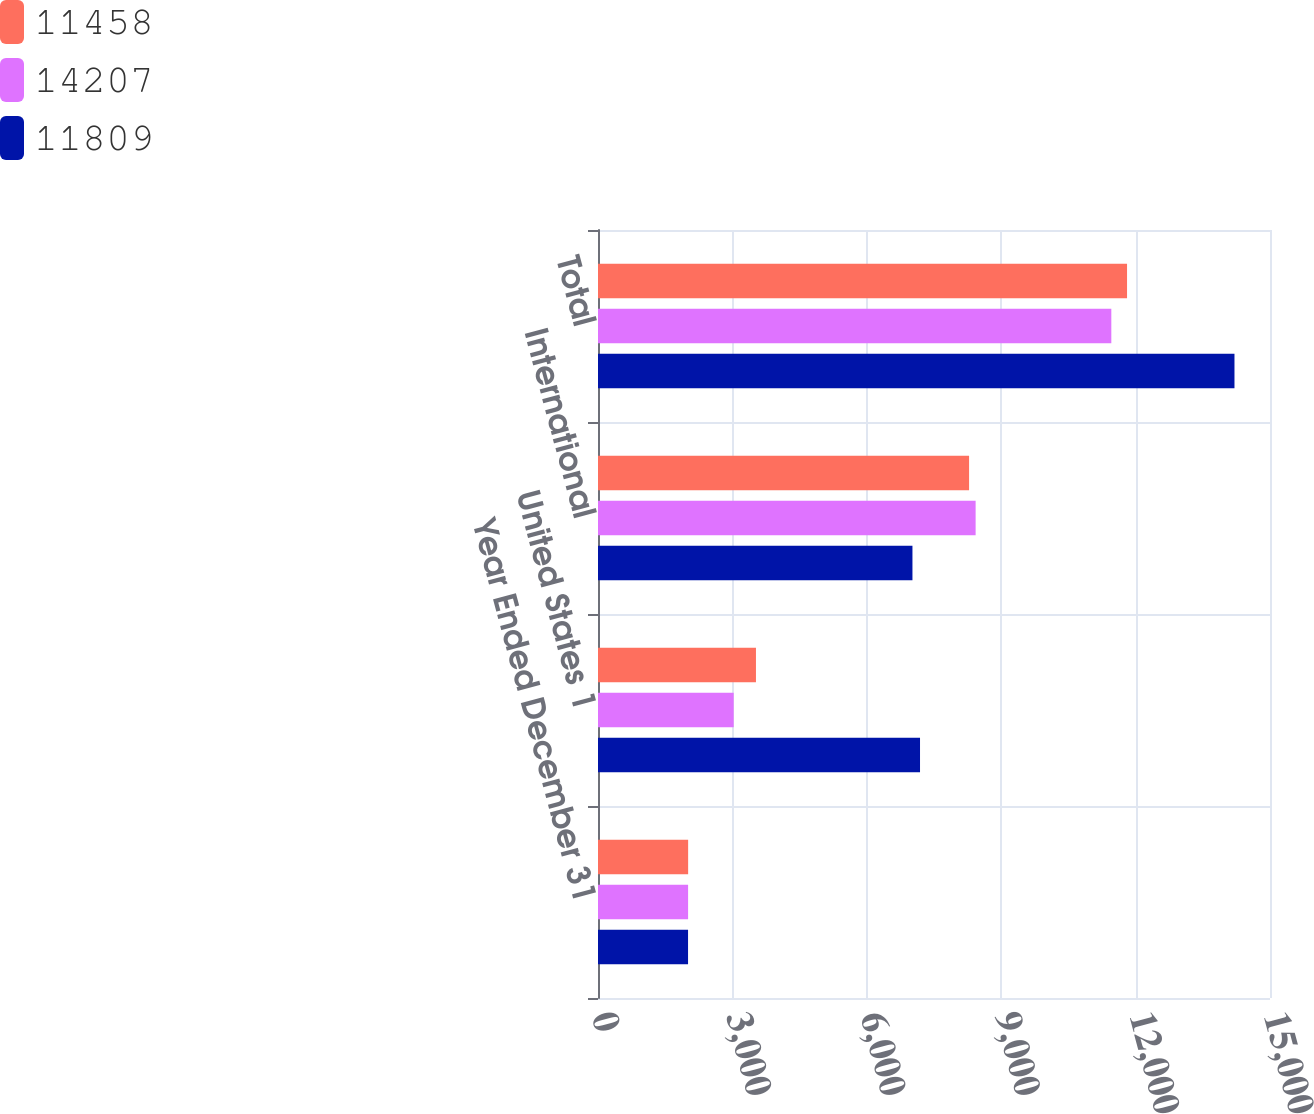Convert chart. <chart><loc_0><loc_0><loc_500><loc_500><stacked_bar_chart><ecel><fcel>Year Ended December 31<fcel>United States 1<fcel>International<fcel>Total<nl><fcel>11458<fcel>2012<fcel>3526<fcel>8283<fcel>11809<nl><fcel>14207<fcel>2011<fcel>3029<fcel>8429<fcel>11458<nl><fcel>11809<fcel>2010<fcel>7188<fcel>7019<fcel>14207<nl></chart> 